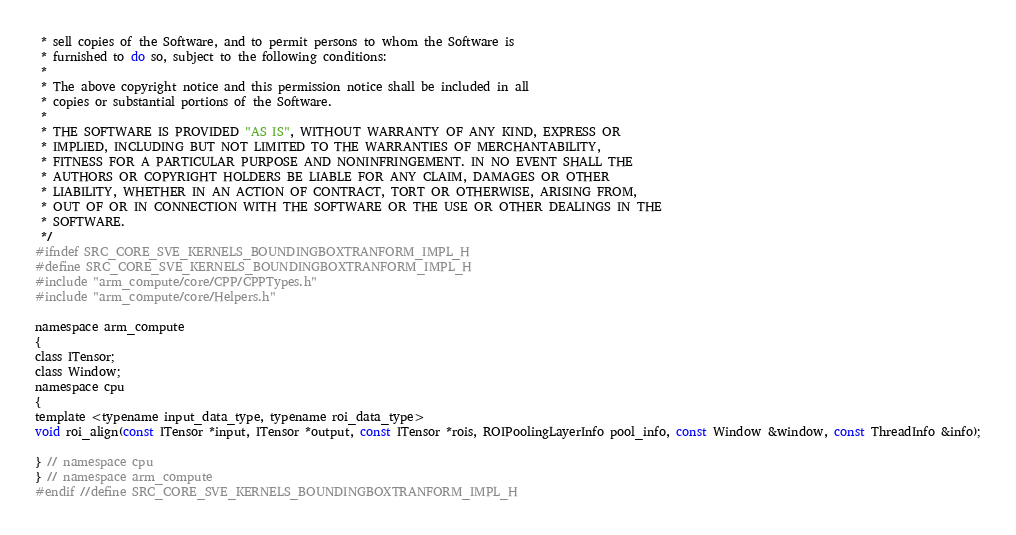Convert code to text. <code><loc_0><loc_0><loc_500><loc_500><_C_> * sell copies of the Software, and to permit persons to whom the Software is
 * furnished to do so, subject to the following conditions:
 *
 * The above copyright notice and this permission notice shall be included in all
 * copies or substantial portions of the Software.
 *
 * THE SOFTWARE IS PROVIDED "AS IS", WITHOUT WARRANTY OF ANY KIND, EXPRESS OR
 * IMPLIED, INCLUDING BUT NOT LIMITED TO THE WARRANTIES OF MERCHANTABILITY,
 * FITNESS FOR A PARTICULAR PURPOSE AND NONINFRINGEMENT. IN NO EVENT SHALL THE
 * AUTHORS OR COPYRIGHT HOLDERS BE LIABLE FOR ANY CLAIM, DAMAGES OR OTHER
 * LIABILITY, WHETHER IN AN ACTION OF CONTRACT, TORT OR OTHERWISE, ARISING FROM,
 * OUT OF OR IN CONNECTION WITH THE SOFTWARE OR THE USE OR OTHER DEALINGS IN THE
 * SOFTWARE.
 */
#ifndef SRC_CORE_SVE_KERNELS_BOUNDINGBOXTRANFORM_IMPL_H
#define SRC_CORE_SVE_KERNELS_BOUNDINGBOXTRANFORM_IMPL_H
#include "arm_compute/core/CPP/CPPTypes.h"
#include "arm_compute/core/Helpers.h"

namespace arm_compute
{
class ITensor;
class Window;
namespace cpu
{
template <typename input_data_type, typename roi_data_type>
void roi_align(const ITensor *input, ITensor *output, const ITensor *rois, ROIPoolingLayerInfo pool_info, const Window &window, const ThreadInfo &info);

} // namespace cpu
} // namespace arm_compute
#endif //define SRC_CORE_SVE_KERNELS_BOUNDINGBOXTRANFORM_IMPL_H
</code> 